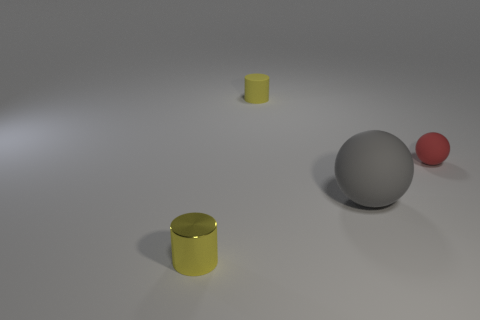Can you estimate the relative sizes of these objects? From the perspective provided, the yellow cylinders and the gray sphere appear to be roughly similar in size, possibly within a few centimeters of each other in height and diameter. The red sphere is visibly smaller than the other objects, potentially about half the diameter of the other shapes. 